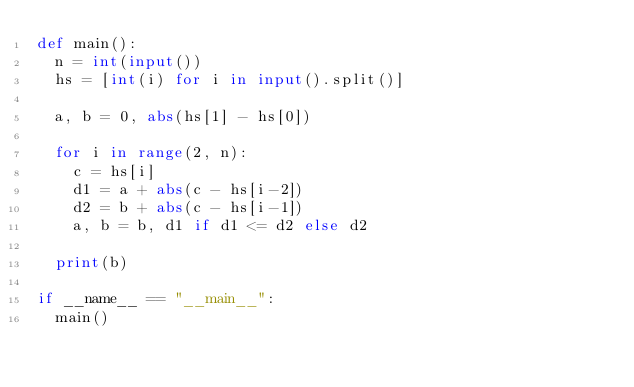<code> <loc_0><loc_0><loc_500><loc_500><_Python_>def main():
  n = int(input())
  hs = [int(i) for i in input().split()]

  a, b = 0, abs(hs[1] - hs[0])

  for i in range(2, n):
    c = hs[i]
    d1 = a + abs(c - hs[i-2])
    d2 = b + abs(c - hs[i-1])
    a, b = b, d1 if d1 <= d2 else d2

  print(b)

if __name__ == "__main__":
  main()
</code> 